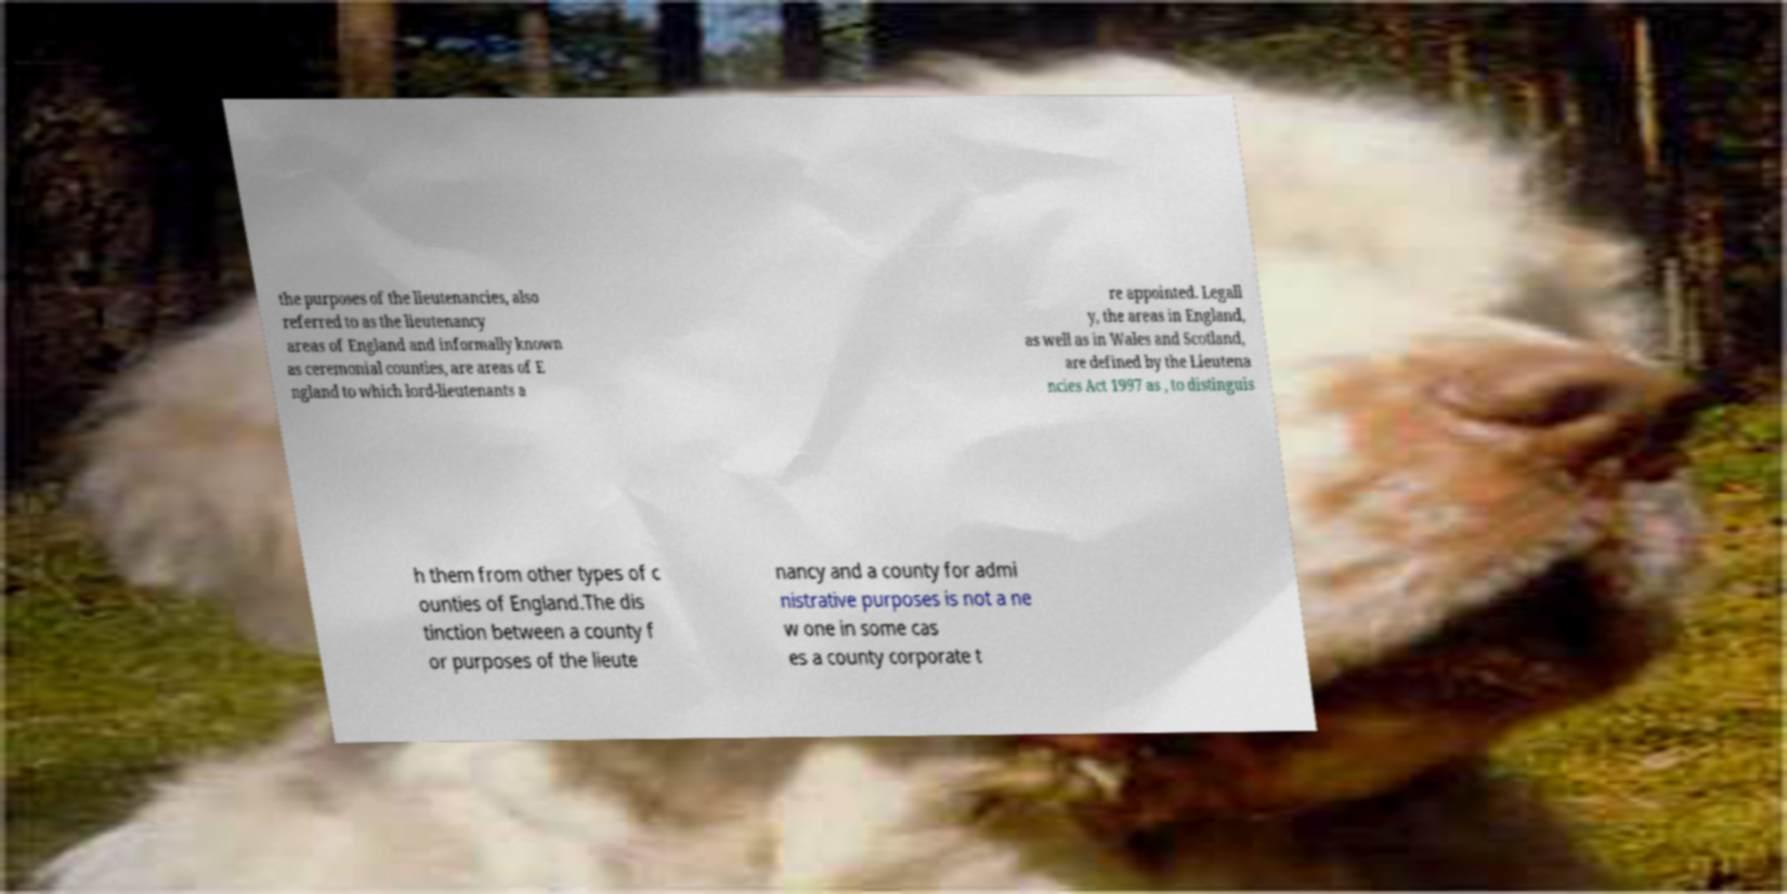For documentation purposes, I need the text within this image transcribed. Could you provide that? the purposes of the lieutenancies, also referred to as the lieutenancy areas of England and informally known as ceremonial counties, are areas of E ngland to which lord-lieutenants a re appointed. Legall y, the areas in England, as well as in Wales and Scotland, are defined by the Lieutena ncies Act 1997 as , to distinguis h them from other types of c ounties of England.The dis tinction between a county f or purposes of the lieute nancy and a county for admi nistrative purposes is not a ne w one in some cas es a county corporate t 